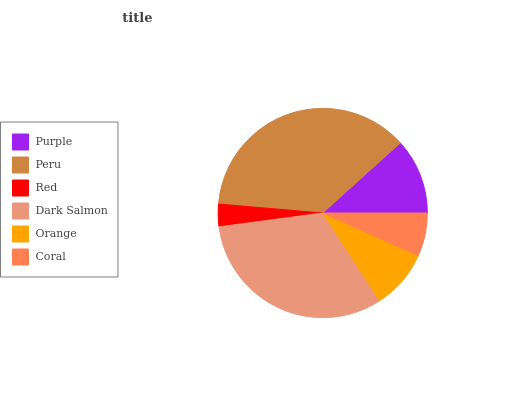Is Red the minimum?
Answer yes or no. Yes. Is Peru the maximum?
Answer yes or no. Yes. Is Peru the minimum?
Answer yes or no. No. Is Red the maximum?
Answer yes or no. No. Is Peru greater than Red?
Answer yes or no. Yes. Is Red less than Peru?
Answer yes or no. Yes. Is Red greater than Peru?
Answer yes or no. No. Is Peru less than Red?
Answer yes or no. No. Is Purple the high median?
Answer yes or no. Yes. Is Orange the low median?
Answer yes or no. Yes. Is Red the high median?
Answer yes or no. No. Is Peru the low median?
Answer yes or no. No. 